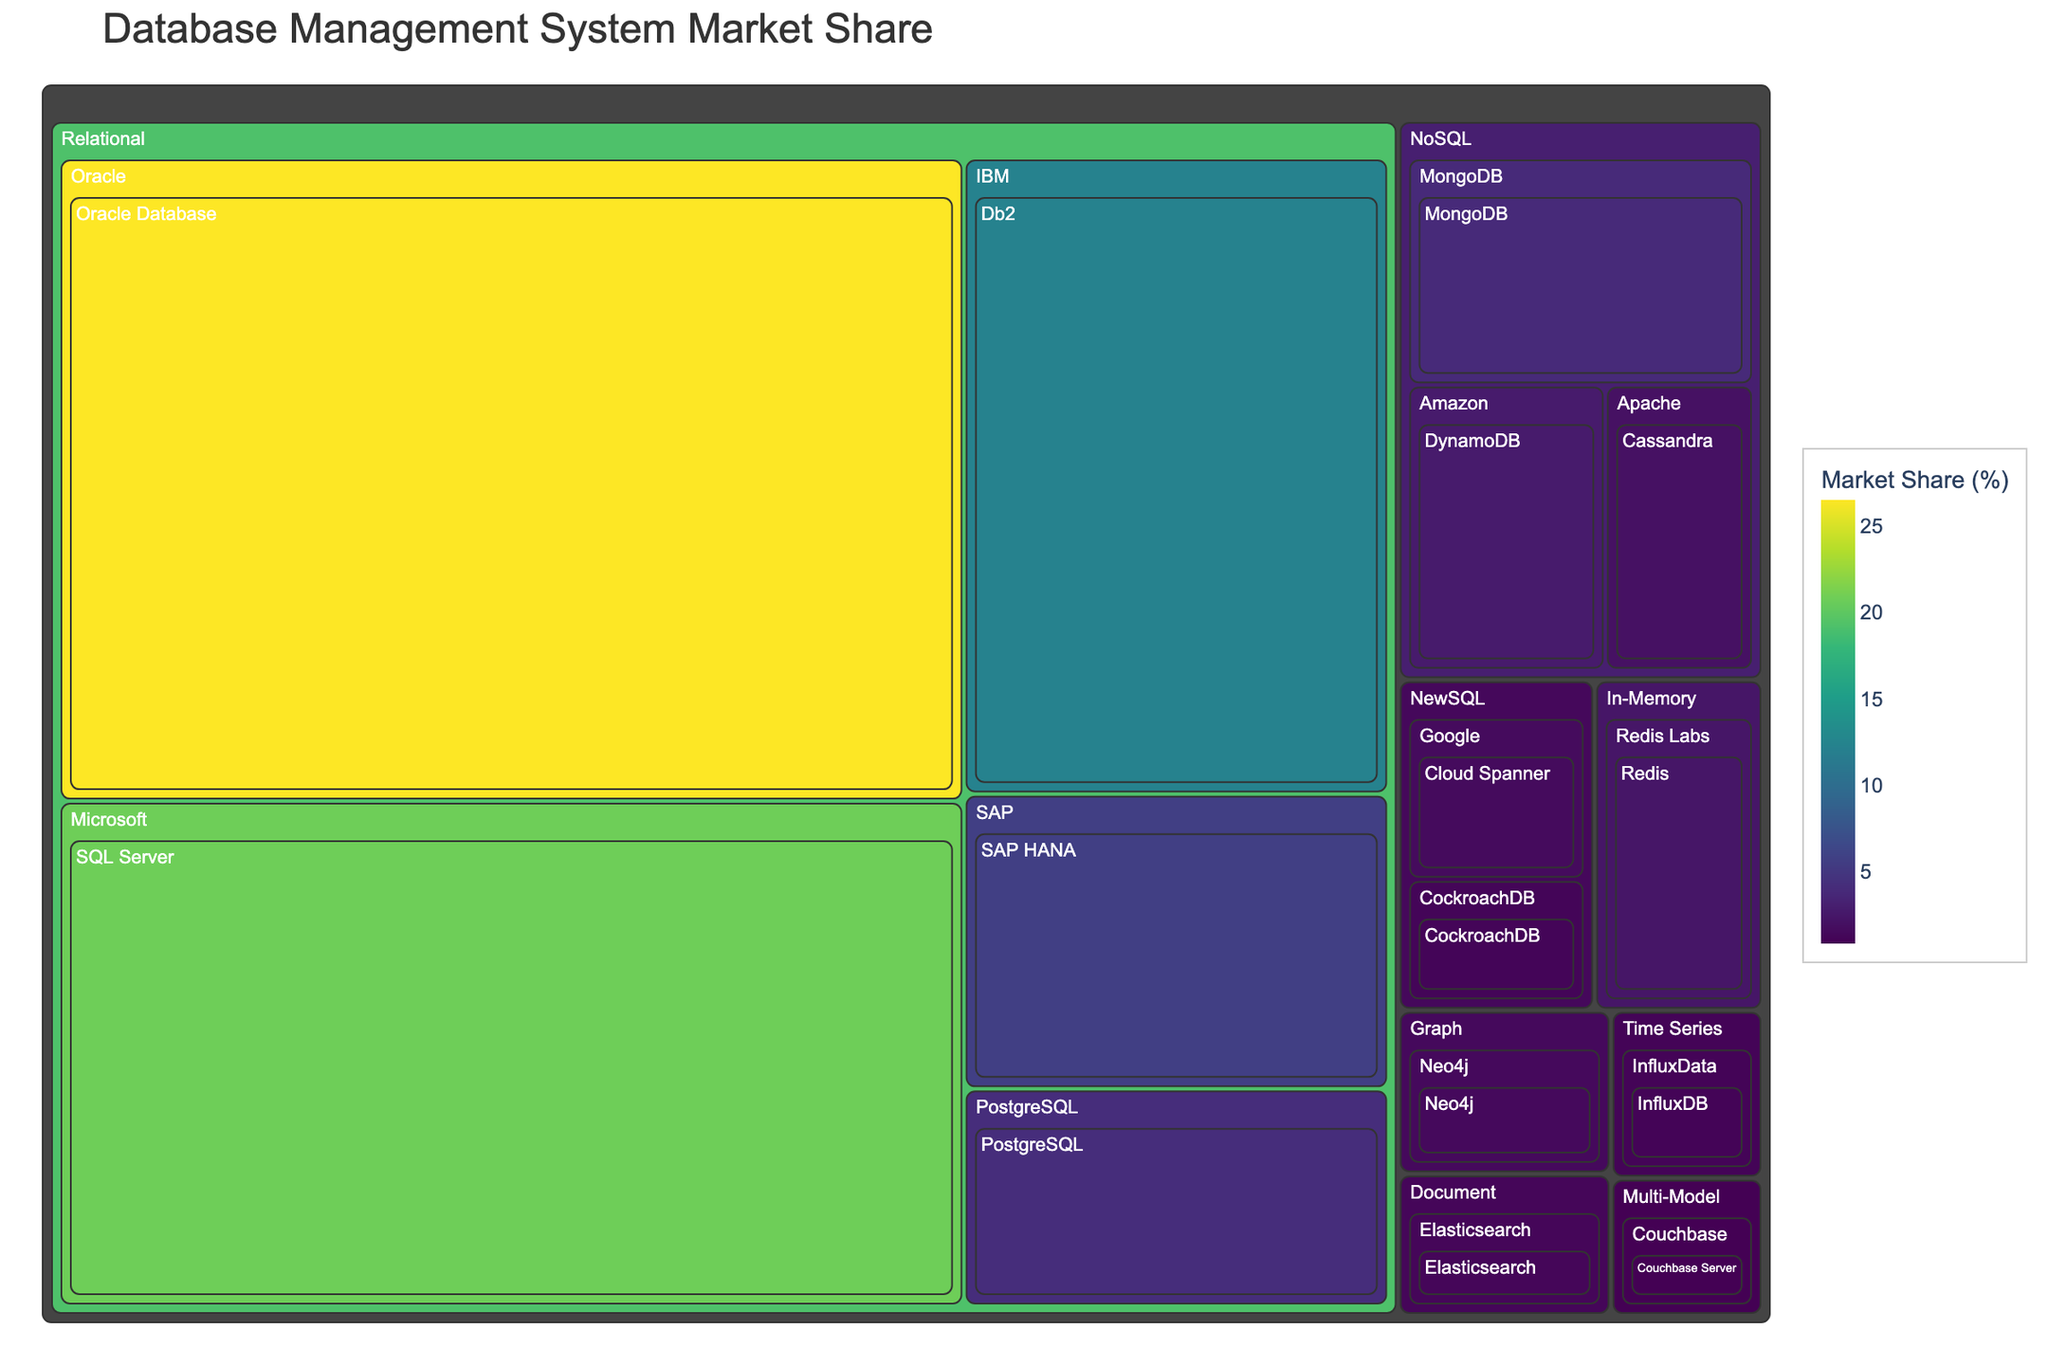What is the title of the Treemap? The title of the Treemap is usually located at the top and provides a summary of the subject being visualized. By looking at the top section of the figure, you can see it clearly displayed.
Answer: Database Management System Market Share Which vendor has the largest market share in the Relational category? Within the Relational category, look for the rectangle with the largest area and check the associated vendor label. Oracle is the vendor with the largest market share in this category.
Answer: Oracle How does the market share of SQL Server compare to MongoDB? Identify the rectangles for SQL Server and MongoDB within their respective categories. The SQL Server rectangle is significantly larger than the MongoDB rectangle, indicating that SQL Server has a much higher market share.
Answer: SQL Server has a higher market share than MongoDB What is the total market share for the NoSQL category? Add up the market shares of all the products in the NoSQL category: 3.9 (MongoDB) + 2.8 (DynamoDB) + 2.1 (Cassandra) = 8.8
Answer: 8.8% How many products belong to the NewSQL category? Count the number of rectangles under the NewSQL category within the Treemap. There are two products: Cloud Spanner and CockroachDB.
Answer: 2 Which product has a higher market share, Redis or Elasticsearch? Compare the sizes of the rectangles for Redis and Elasticsearch within their respective categories. Redis has a market share of 2.4%, while Elasticsearch has a market share of 1.3%.
Answer: Redis What is the smallest market share shown in the figure, and which product does it belong to? Look for the smallest rectangle within the Treemap, which represents the product Couchbase Server under the Multi-Model category with a market share of 0.9%.
Answer: Couchbase Server, 0.9% What is the market share difference between Oracle Database and SAP HANA? Subtract the market share of SAP HANA (5.7%) from the market share of Oracle Database (26.5%): 26.5 - 5.7 = 20.8
Answer: 20.8% Which category has the least representation in terms of the number of products, and what are those products? Identify the categories with only one or very few products. The Time Series and Graph categories each have only one product, InfluxDB and Neo4j, respectively.
Answer: Time Series (InfluxDB) and Graph (Neo4j) 